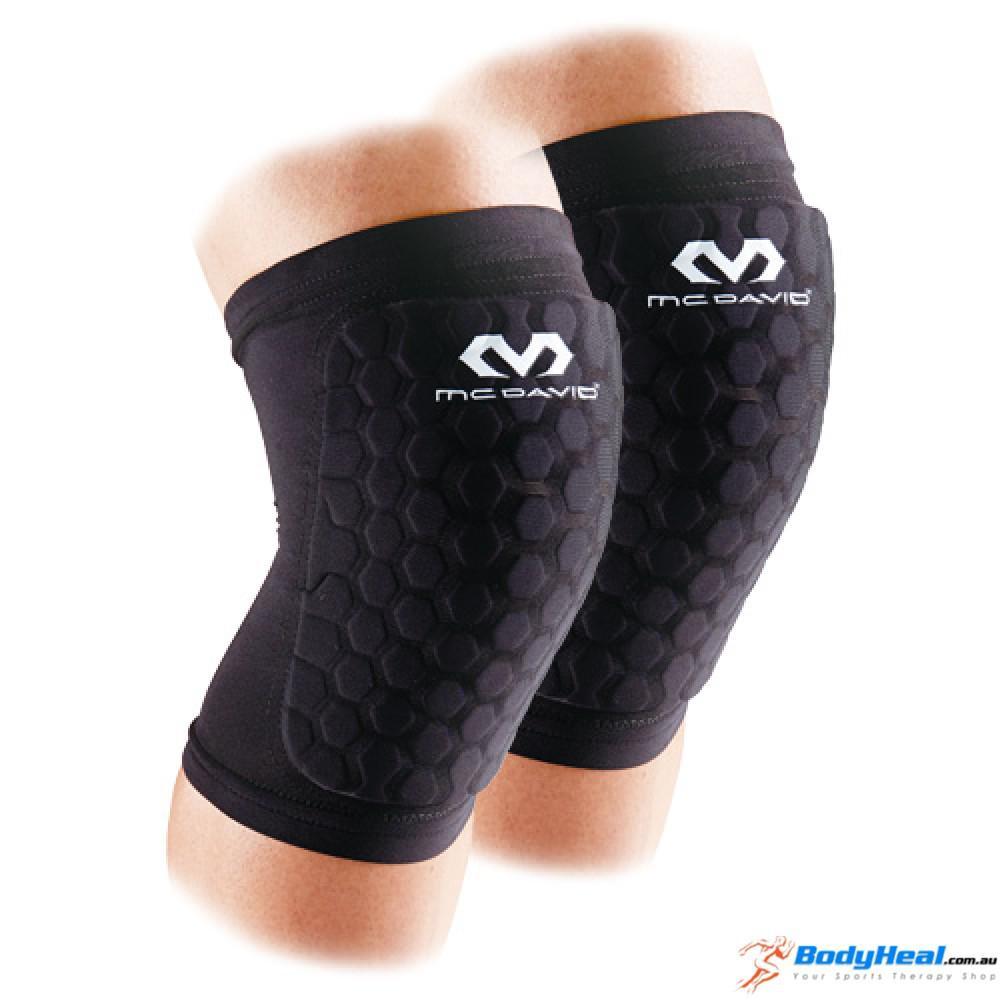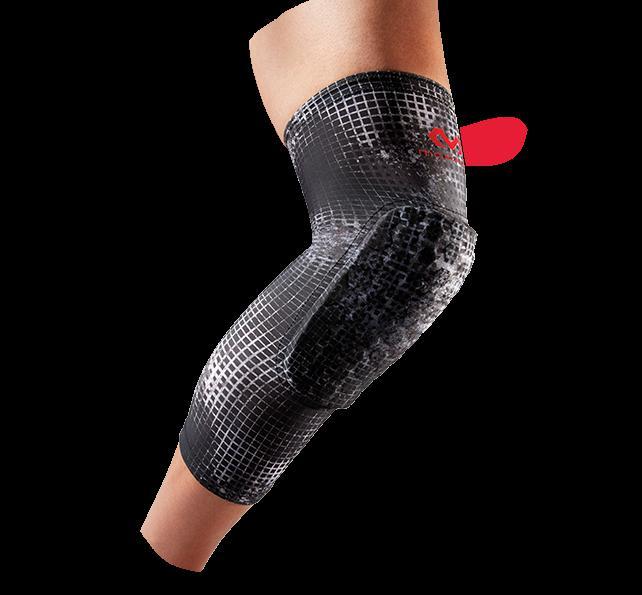The first image is the image on the left, the second image is the image on the right. For the images displayed, is the sentence "Exactly two knee braces are positioned on legs to show their proper use." factually correct? Answer yes or no. No. 